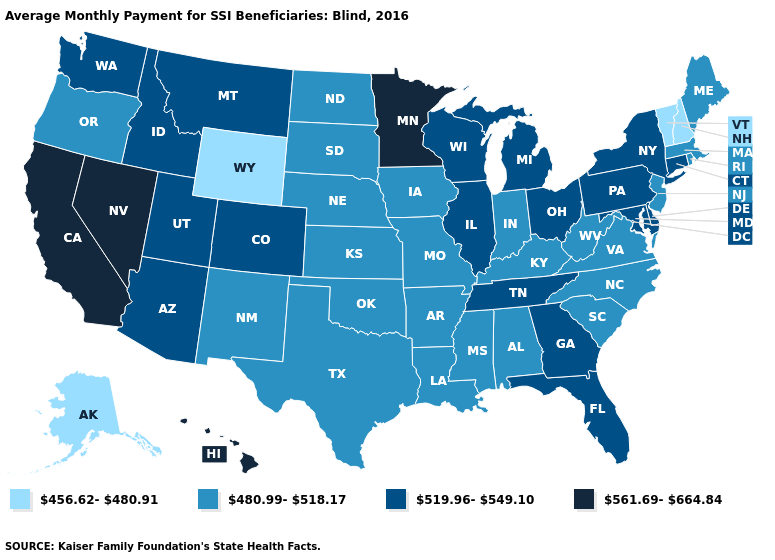Which states hav the highest value in the South?
Short answer required. Delaware, Florida, Georgia, Maryland, Tennessee. Among the states that border Idaho , which have the lowest value?
Give a very brief answer. Wyoming. Name the states that have a value in the range 480.99-518.17?
Quick response, please. Alabama, Arkansas, Indiana, Iowa, Kansas, Kentucky, Louisiana, Maine, Massachusetts, Mississippi, Missouri, Nebraska, New Jersey, New Mexico, North Carolina, North Dakota, Oklahoma, Oregon, Rhode Island, South Carolina, South Dakota, Texas, Virginia, West Virginia. What is the value of Louisiana?
Give a very brief answer. 480.99-518.17. How many symbols are there in the legend?
Short answer required. 4. Name the states that have a value in the range 480.99-518.17?
Quick response, please. Alabama, Arkansas, Indiana, Iowa, Kansas, Kentucky, Louisiana, Maine, Massachusetts, Mississippi, Missouri, Nebraska, New Jersey, New Mexico, North Carolina, North Dakota, Oklahoma, Oregon, Rhode Island, South Carolina, South Dakota, Texas, Virginia, West Virginia. What is the value of North Dakota?
Answer briefly. 480.99-518.17. What is the value of Mississippi?
Give a very brief answer. 480.99-518.17. Name the states that have a value in the range 519.96-549.10?
Concise answer only. Arizona, Colorado, Connecticut, Delaware, Florida, Georgia, Idaho, Illinois, Maryland, Michigan, Montana, New York, Ohio, Pennsylvania, Tennessee, Utah, Washington, Wisconsin. What is the value of Nevada?
Be succinct. 561.69-664.84. What is the value of Tennessee?
Answer briefly. 519.96-549.10. Name the states that have a value in the range 519.96-549.10?
Short answer required. Arizona, Colorado, Connecticut, Delaware, Florida, Georgia, Idaho, Illinois, Maryland, Michigan, Montana, New York, Ohio, Pennsylvania, Tennessee, Utah, Washington, Wisconsin. What is the value of Washington?
Answer briefly. 519.96-549.10. What is the highest value in the Northeast ?
Write a very short answer. 519.96-549.10. 